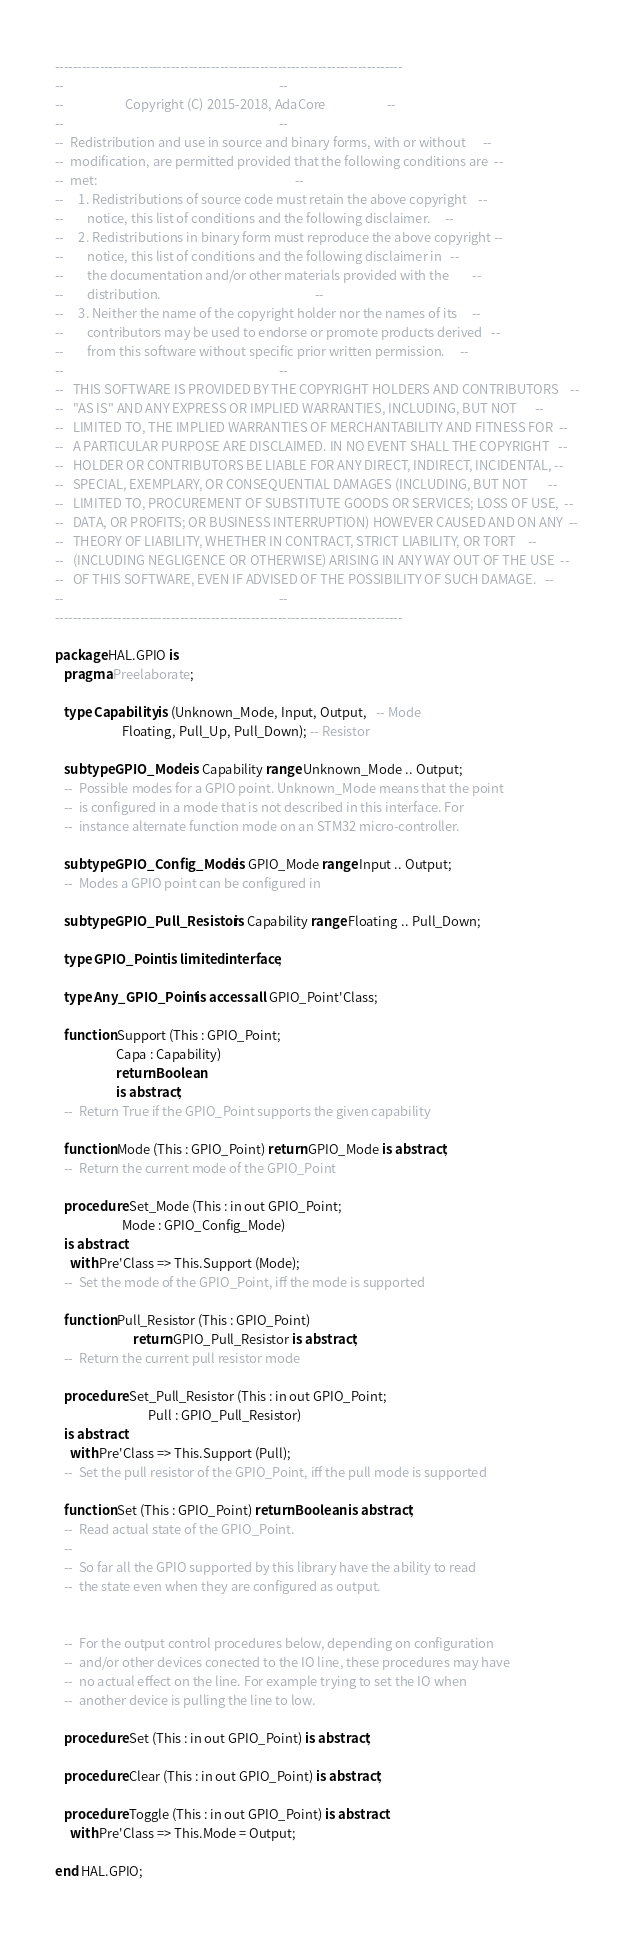Convert code to text. <code><loc_0><loc_0><loc_500><loc_500><_Ada_>------------------------------------------------------------------------------
--                                                                          --
--                     Copyright (C) 2015-2018, AdaCore                     --
--                                                                          --
--  Redistribution and use in source and binary forms, with or without      --
--  modification, are permitted provided that the following conditions are  --
--  met:                                                                    --
--     1. Redistributions of source code must retain the above copyright    --
--        notice, this list of conditions and the following disclaimer.     --
--     2. Redistributions in binary form must reproduce the above copyright --
--        notice, this list of conditions and the following disclaimer in   --
--        the documentation and/or other materials provided with the        --
--        distribution.                                                     --
--     3. Neither the name of the copyright holder nor the names of its     --
--        contributors may be used to endorse or promote products derived   --
--        from this software without specific prior written permission.     --
--                                                                          --
--   THIS SOFTWARE IS PROVIDED BY THE COPYRIGHT HOLDERS AND CONTRIBUTORS    --
--   "AS IS" AND ANY EXPRESS OR IMPLIED WARRANTIES, INCLUDING, BUT NOT      --
--   LIMITED TO, THE IMPLIED WARRANTIES OF MERCHANTABILITY AND FITNESS FOR  --
--   A PARTICULAR PURPOSE ARE DISCLAIMED. IN NO EVENT SHALL THE COPYRIGHT   --
--   HOLDER OR CONTRIBUTORS BE LIABLE FOR ANY DIRECT, INDIRECT, INCIDENTAL, --
--   SPECIAL, EXEMPLARY, OR CONSEQUENTIAL DAMAGES (INCLUDING, BUT NOT       --
--   LIMITED TO, PROCUREMENT OF SUBSTITUTE GOODS OR SERVICES; LOSS OF USE,  --
--   DATA, OR PROFITS; OR BUSINESS INTERRUPTION) HOWEVER CAUSED AND ON ANY  --
--   THEORY OF LIABILITY, WHETHER IN CONTRACT, STRICT LIABILITY, OR TORT    --
--   (INCLUDING NEGLIGENCE OR OTHERWISE) ARISING IN ANY WAY OUT OF THE USE  --
--   OF THIS SOFTWARE, EVEN IF ADVISED OF THE POSSIBILITY OF SUCH DAMAGE.   --
--                                                                          --
------------------------------------------------------------------------------

package HAL.GPIO is
   pragma Preelaborate;

   type Capability is (Unknown_Mode, Input, Output,   -- Mode
                       Floating, Pull_Up, Pull_Down); -- Resistor

   subtype GPIO_Mode is Capability range Unknown_Mode .. Output;
   --  Possible modes for a GPIO point. Unknown_Mode means that the point
   --  is configured in a mode that is not described in this interface. For
   --  instance alternate function mode on an STM32 micro-controller.

   subtype GPIO_Config_Mode is GPIO_Mode range Input .. Output;
   --  Modes a GPIO point can be configured in

   subtype GPIO_Pull_Resistor is Capability range Floating .. Pull_Down;

   type GPIO_Point is limited interface;

   type Any_GPIO_Point is access all GPIO_Point'Class;

   function Support (This : GPIO_Point;
                     Capa : Capability)
                     return Boolean
                     is abstract;
   --  Return True if the GPIO_Point supports the given capability

   function Mode (This : GPIO_Point) return GPIO_Mode is abstract;
   --  Return the current mode of the GPIO_Point

   procedure Set_Mode (This : in out GPIO_Point;
                       Mode : GPIO_Config_Mode)
   is abstract
     with Pre'Class => This.Support (Mode);
   --  Set the mode of the GPIO_Point, iff the mode is supported

   function Pull_Resistor (This : GPIO_Point)
                           return GPIO_Pull_Resistor is abstract;
   --  Return the current pull resistor mode

   procedure Set_Pull_Resistor (This : in out GPIO_Point;
                                Pull : GPIO_Pull_Resistor)
   is abstract
     with Pre'Class => This.Support (Pull);
   --  Set the pull resistor of the GPIO_Point, iff the pull mode is supported

   function Set (This : GPIO_Point) return Boolean is abstract;
   --  Read actual state of the GPIO_Point.
   --
   --  So far all the GPIO supported by this library have the ability to read
   --  the state even when they are configured as output.


   --  For the output control procedures below, depending on configuration
   --  and/or other devices conected to the IO line, these procedures may have
   --  no actual effect on the line. For example trying to set the IO when
   --  another device is pulling the line to low.

   procedure Set (This : in out GPIO_Point) is abstract;

   procedure Clear (This : in out GPIO_Point) is abstract;

   procedure Toggle (This : in out GPIO_Point) is abstract
     with Pre'Class => This.Mode = Output;

end HAL.GPIO;
</code> 